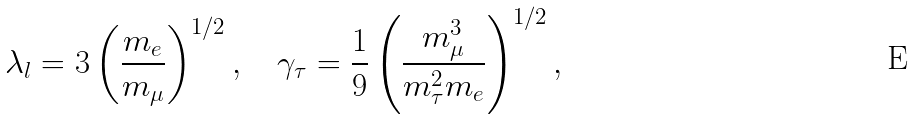<formula> <loc_0><loc_0><loc_500><loc_500>\lambda _ { l } = 3 \left ( \frac { m _ { e } } { m _ { \mu } } \right ) ^ { 1 / 2 } , \quad \gamma _ { \tau } = \frac { 1 } { 9 } \left ( \frac { m _ { \mu } ^ { 3 } } { m _ { \tau } ^ { 2 } m _ { e } } \right ) ^ { 1 / 2 } ,</formula> 